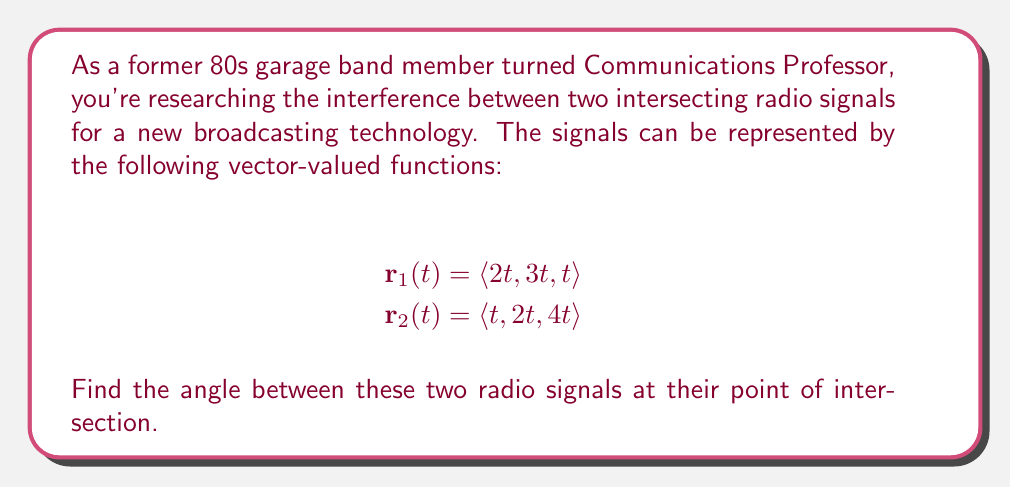Solve this math problem. To find the angle between two intersecting vector-valued functions, we can follow these steps:

1) First, we need to find the direction vectors of both signals. These are given by the coefficients of t in each function:

   $\mathbf{v}_1 = \langle 2, 3, 1 \rangle$
   $\mathbf{v}_2 = \langle 1, 2, 4 \rangle$

2) The angle between two vectors can be found using the dot product formula:

   $$\cos \theta = \frac{\mathbf{v}_1 \cdot \mathbf{v}_2}{|\mathbf{v}_1||\mathbf{v}_2|}$$

3) Let's calculate the dot product $\mathbf{v}_1 \cdot \mathbf{v}_2$:
   
   $\mathbf{v}_1 \cdot \mathbf{v}_2 = (2)(1) + (3)(2) + (1)(4) = 2 + 6 + 4 = 12$

4) Now, let's calculate the magnitudes of $\mathbf{v}_1$ and $\mathbf{v}_2$:

   $|\mathbf{v}_1| = \sqrt{2^2 + 3^2 + 1^2} = \sqrt{14}$
   $|\mathbf{v}_2| = \sqrt{1^2 + 2^2 + 4^2} = \sqrt{21}$

5) Substituting these values into the formula:

   $$\cos \theta = \frac{12}{\sqrt{14}\sqrt{21}}$$

6) To find $\theta$, we take the inverse cosine (arccos) of both sides:

   $$\theta = \arccos\left(\frac{12}{\sqrt{14}\sqrt{21}}\right)$$

7) Using a calculator, we can evaluate this expression.
Answer: The angle between the two radio signals is approximately 0.5456 radians or 31.26 degrees. 